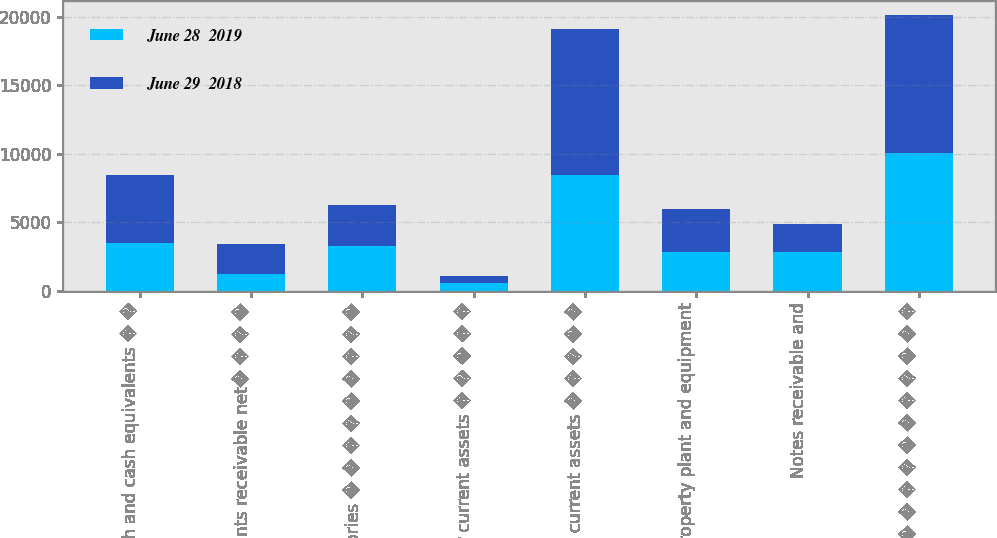<chart> <loc_0><loc_0><loc_500><loc_500><stacked_bar_chart><ecel><fcel>Cash and cash equivalents � �<fcel>Accounts receivable net� � � �<fcel>Inventories � � � � � � � � �<fcel>Other current assets � � � � �<fcel>Total current assets � � � � �<fcel>Property plant and equipment<fcel>Notes receivable and<fcel>Goodwill � � � � � � � � � � �<nl><fcel>June 28  2019<fcel>3455<fcel>1204<fcel>3283<fcel>535<fcel>8477<fcel>2843<fcel>2791<fcel>10076<nl><fcel>June 29  2018<fcel>5005<fcel>2197<fcel>2944<fcel>492<fcel>10638<fcel>3095<fcel>2105<fcel>10075<nl></chart> 